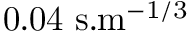<formula> <loc_0><loc_0><loc_500><loc_500>0 . 0 4 s . m ^ { - 1 / 3 }</formula> 